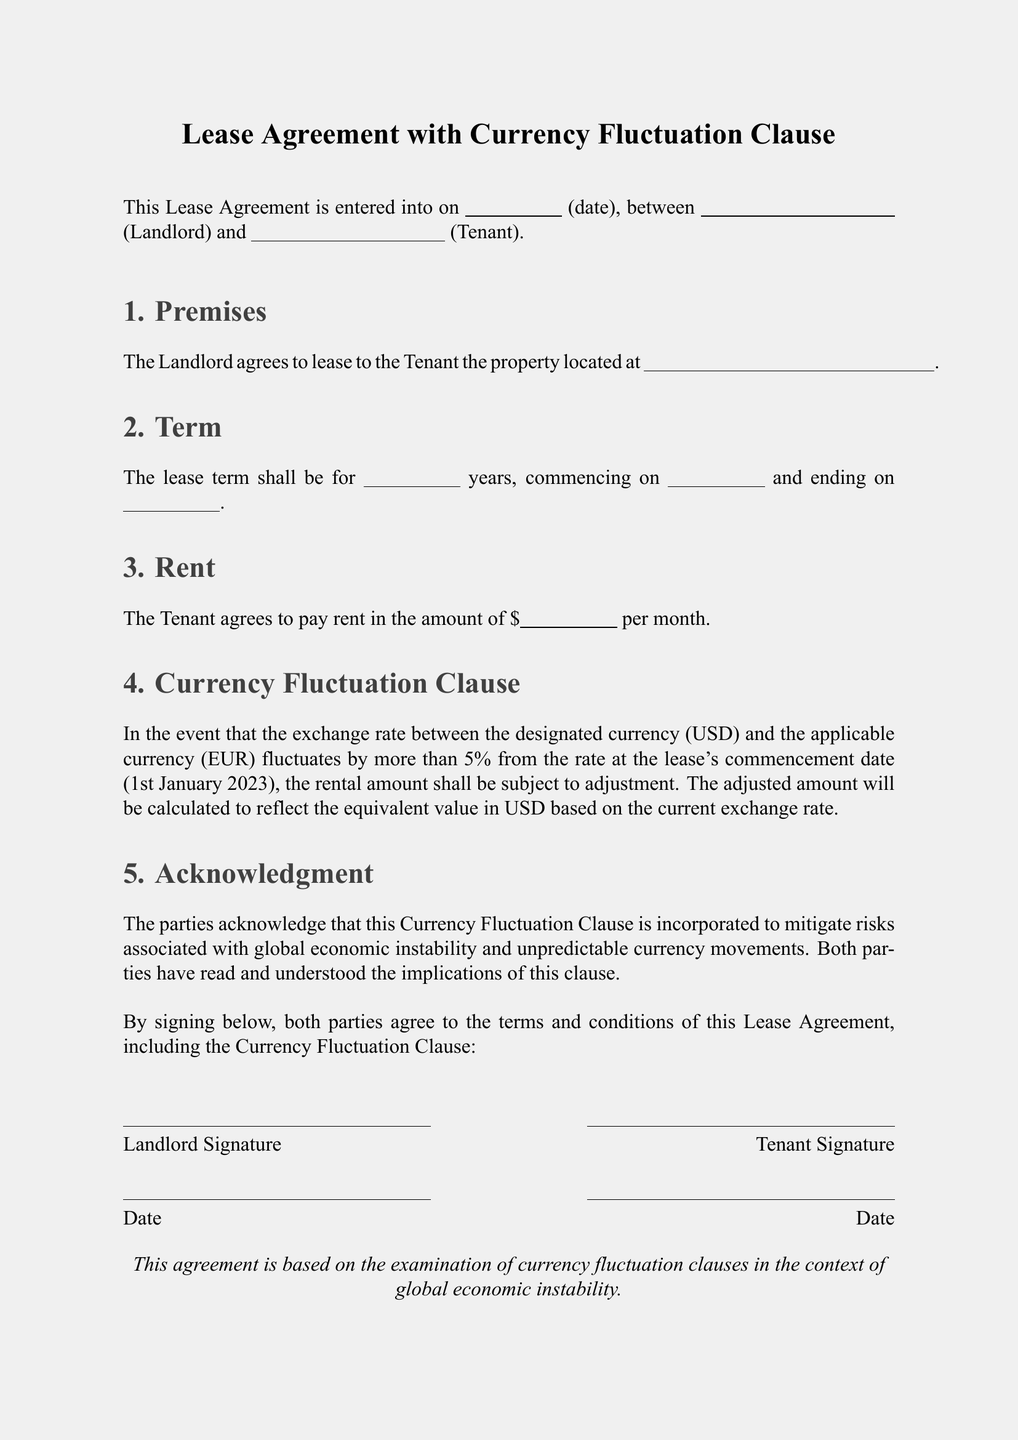What is the date of lease commencement? The document specifies the commencement date for the lease in a blank space, typically filled out as the date agreed upon by both parties.
Answer: 1st January 2023 What is the maximum fluctuation percentage mentioned? The document outlines a currency fluctuation threshold of more than 5% for adjustments to be applicable.
Answer: 5% Who are the parties involved in the Lease Agreement? The document indicates that there are two parties, the Landlord and the Tenant, who sign the agreement.
Answer: Landlord and Tenant What does the Currency Fluctuation Clause aim to mitigate? The clause is incorporated to mitigate risks associated with global economic instability and unpredictable currency movements.
Answer: Risks associated with global economic instability What is the rental amount to be paid each month? The rental payment is designated in a blank space where the specific amount should be filled in by the Tenant.
Answer: [amount to be filled] What type of clause is included in the Lease Agreement? The document explicitly includes a Currency Fluctuation Clause.
Answer: Currency Fluctuation Clause What is the duration of the lease term specified in the document? The lease term duration is stated in a blank space, where the specific number of years would be filled in by the parties.
Answer: [number to be filled] What is the effect of a currency fluctuation beyond 5%? If the exchange rate fluctuates by more than 5%, the rental amount shall be subject to adjustment to reflect the equivalent value in USD.
Answer: Subject to adjustment What does "USD" refer to in the Lease Agreement? USD refers to the United States Dollar, the designated currency for the lease agreement.
Answer: United States Dollar 